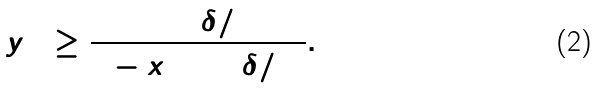<formula> <loc_0><loc_0><loc_500><loc_500>\hat { y } _ { 1 3 } \geq \frac { \cos ^ { 2 } ( \delta / 2 ) } { 1 - x _ { 3 } \sin ^ { 2 } ( \delta / 2 ) } .</formula> 